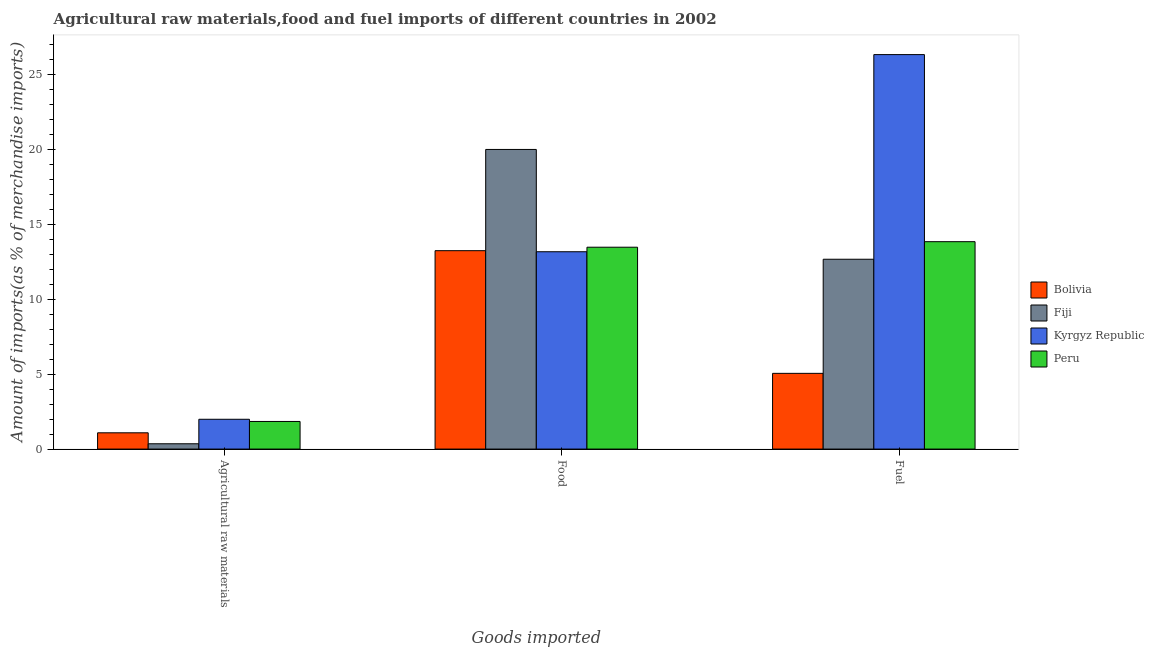How many different coloured bars are there?
Your answer should be compact. 4. Are the number of bars per tick equal to the number of legend labels?
Make the answer very short. Yes. How many bars are there on the 3rd tick from the left?
Provide a succinct answer. 4. What is the label of the 3rd group of bars from the left?
Give a very brief answer. Fuel. What is the percentage of raw materials imports in Kyrgyz Republic?
Your answer should be compact. 1.99. Across all countries, what is the maximum percentage of fuel imports?
Give a very brief answer. 26.32. Across all countries, what is the minimum percentage of fuel imports?
Ensure brevity in your answer.  5.05. In which country was the percentage of raw materials imports maximum?
Your answer should be very brief. Kyrgyz Republic. In which country was the percentage of fuel imports minimum?
Offer a very short reply. Bolivia. What is the total percentage of fuel imports in the graph?
Your answer should be very brief. 57.87. What is the difference between the percentage of fuel imports in Bolivia and that in Fiji?
Your answer should be compact. -7.61. What is the difference between the percentage of raw materials imports in Kyrgyz Republic and the percentage of fuel imports in Fiji?
Your answer should be compact. -10.68. What is the average percentage of food imports per country?
Your response must be concise. 14.97. What is the difference between the percentage of fuel imports and percentage of raw materials imports in Kyrgyz Republic?
Make the answer very short. 24.33. What is the ratio of the percentage of food imports in Fiji to that in Kyrgyz Republic?
Provide a succinct answer. 1.52. Is the difference between the percentage of fuel imports in Fiji and Bolivia greater than the difference between the percentage of food imports in Fiji and Bolivia?
Keep it short and to the point. Yes. What is the difference between the highest and the second highest percentage of food imports?
Give a very brief answer. 6.52. What is the difference between the highest and the lowest percentage of fuel imports?
Your response must be concise. 21.27. What does the 4th bar from the left in Agricultural raw materials represents?
Provide a short and direct response. Peru. What does the 4th bar from the right in Agricultural raw materials represents?
Make the answer very short. Bolivia. How many bars are there?
Give a very brief answer. 12. Are all the bars in the graph horizontal?
Make the answer very short. No. How many countries are there in the graph?
Keep it short and to the point. 4. Are the values on the major ticks of Y-axis written in scientific E-notation?
Your answer should be compact. No. Does the graph contain any zero values?
Make the answer very short. No. Does the graph contain grids?
Give a very brief answer. No. Where does the legend appear in the graph?
Provide a succinct answer. Center right. How many legend labels are there?
Give a very brief answer. 4. What is the title of the graph?
Provide a succinct answer. Agricultural raw materials,food and fuel imports of different countries in 2002. What is the label or title of the X-axis?
Offer a very short reply. Goods imported. What is the label or title of the Y-axis?
Offer a very short reply. Amount of imports(as % of merchandise imports). What is the Amount of imports(as % of merchandise imports) of Bolivia in Agricultural raw materials?
Make the answer very short. 1.09. What is the Amount of imports(as % of merchandise imports) of Fiji in Agricultural raw materials?
Give a very brief answer. 0.35. What is the Amount of imports(as % of merchandise imports) of Kyrgyz Republic in Agricultural raw materials?
Your answer should be compact. 1.99. What is the Amount of imports(as % of merchandise imports) of Peru in Agricultural raw materials?
Offer a terse response. 1.84. What is the Amount of imports(as % of merchandise imports) in Bolivia in Food?
Provide a short and direct response. 13.24. What is the Amount of imports(as % of merchandise imports) of Fiji in Food?
Keep it short and to the point. 19.99. What is the Amount of imports(as % of merchandise imports) of Kyrgyz Republic in Food?
Give a very brief answer. 13.17. What is the Amount of imports(as % of merchandise imports) in Peru in Food?
Offer a very short reply. 13.47. What is the Amount of imports(as % of merchandise imports) of Bolivia in Fuel?
Provide a succinct answer. 5.05. What is the Amount of imports(as % of merchandise imports) of Fiji in Fuel?
Your answer should be compact. 12.67. What is the Amount of imports(as % of merchandise imports) in Kyrgyz Republic in Fuel?
Your answer should be compact. 26.32. What is the Amount of imports(as % of merchandise imports) of Peru in Fuel?
Offer a terse response. 13.84. Across all Goods imported, what is the maximum Amount of imports(as % of merchandise imports) in Bolivia?
Provide a succinct answer. 13.24. Across all Goods imported, what is the maximum Amount of imports(as % of merchandise imports) in Fiji?
Provide a succinct answer. 19.99. Across all Goods imported, what is the maximum Amount of imports(as % of merchandise imports) of Kyrgyz Republic?
Ensure brevity in your answer.  26.32. Across all Goods imported, what is the maximum Amount of imports(as % of merchandise imports) in Peru?
Ensure brevity in your answer.  13.84. Across all Goods imported, what is the minimum Amount of imports(as % of merchandise imports) in Bolivia?
Your response must be concise. 1.09. Across all Goods imported, what is the minimum Amount of imports(as % of merchandise imports) in Fiji?
Offer a terse response. 0.35. Across all Goods imported, what is the minimum Amount of imports(as % of merchandise imports) of Kyrgyz Republic?
Make the answer very short. 1.99. Across all Goods imported, what is the minimum Amount of imports(as % of merchandise imports) in Peru?
Provide a short and direct response. 1.84. What is the total Amount of imports(as % of merchandise imports) of Bolivia in the graph?
Your answer should be very brief. 19.38. What is the total Amount of imports(as % of merchandise imports) in Fiji in the graph?
Make the answer very short. 33.01. What is the total Amount of imports(as % of merchandise imports) in Kyrgyz Republic in the graph?
Offer a terse response. 41.47. What is the total Amount of imports(as % of merchandise imports) in Peru in the graph?
Provide a short and direct response. 29.15. What is the difference between the Amount of imports(as % of merchandise imports) of Bolivia in Agricultural raw materials and that in Food?
Your response must be concise. -12.15. What is the difference between the Amount of imports(as % of merchandise imports) in Fiji in Agricultural raw materials and that in Food?
Make the answer very short. -19.64. What is the difference between the Amount of imports(as % of merchandise imports) in Kyrgyz Republic in Agricultural raw materials and that in Food?
Provide a succinct answer. -11.18. What is the difference between the Amount of imports(as % of merchandise imports) of Peru in Agricultural raw materials and that in Food?
Your answer should be very brief. -11.63. What is the difference between the Amount of imports(as % of merchandise imports) in Bolivia in Agricultural raw materials and that in Fuel?
Ensure brevity in your answer.  -3.97. What is the difference between the Amount of imports(as % of merchandise imports) of Fiji in Agricultural raw materials and that in Fuel?
Give a very brief answer. -12.31. What is the difference between the Amount of imports(as % of merchandise imports) in Kyrgyz Republic in Agricultural raw materials and that in Fuel?
Your answer should be very brief. -24.33. What is the difference between the Amount of imports(as % of merchandise imports) of Peru in Agricultural raw materials and that in Fuel?
Your response must be concise. -12. What is the difference between the Amount of imports(as % of merchandise imports) of Bolivia in Food and that in Fuel?
Keep it short and to the point. 8.18. What is the difference between the Amount of imports(as % of merchandise imports) in Fiji in Food and that in Fuel?
Make the answer very short. 7.33. What is the difference between the Amount of imports(as % of merchandise imports) of Kyrgyz Republic in Food and that in Fuel?
Your answer should be compact. -13.15. What is the difference between the Amount of imports(as % of merchandise imports) of Peru in Food and that in Fuel?
Keep it short and to the point. -0.37. What is the difference between the Amount of imports(as % of merchandise imports) of Bolivia in Agricultural raw materials and the Amount of imports(as % of merchandise imports) of Fiji in Food?
Your answer should be very brief. -18.91. What is the difference between the Amount of imports(as % of merchandise imports) of Bolivia in Agricultural raw materials and the Amount of imports(as % of merchandise imports) of Kyrgyz Republic in Food?
Give a very brief answer. -12.08. What is the difference between the Amount of imports(as % of merchandise imports) of Bolivia in Agricultural raw materials and the Amount of imports(as % of merchandise imports) of Peru in Food?
Make the answer very short. -12.38. What is the difference between the Amount of imports(as % of merchandise imports) in Fiji in Agricultural raw materials and the Amount of imports(as % of merchandise imports) in Kyrgyz Republic in Food?
Give a very brief answer. -12.81. What is the difference between the Amount of imports(as % of merchandise imports) in Fiji in Agricultural raw materials and the Amount of imports(as % of merchandise imports) in Peru in Food?
Keep it short and to the point. -13.11. What is the difference between the Amount of imports(as % of merchandise imports) in Kyrgyz Republic in Agricultural raw materials and the Amount of imports(as % of merchandise imports) in Peru in Food?
Provide a succinct answer. -11.48. What is the difference between the Amount of imports(as % of merchandise imports) of Bolivia in Agricultural raw materials and the Amount of imports(as % of merchandise imports) of Fiji in Fuel?
Give a very brief answer. -11.58. What is the difference between the Amount of imports(as % of merchandise imports) in Bolivia in Agricultural raw materials and the Amount of imports(as % of merchandise imports) in Kyrgyz Republic in Fuel?
Keep it short and to the point. -25.23. What is the difference between the Amount of imports(as % of merchandise imports) in Bolivia in Agricultural raw materials and the Amount of imports(as % of merchandise imports) in Peru in Fuel?
Your answer should be very brief. -12.75. What is the difference between the Amount of imports(as % of merchandise imports) of Fiji in Agricultural raw materials and the Amount of imports(as % of merchandise imports) of Kyrgyz Republic in Fuel?
Ensure brevity in your answer.  -25.97. What is the difference between the Amount of imports(as % of merchandise imports) in Fiji in Agricultural raw materials and the Amount of imports(as % of merchandise imports) in Peru in Fuel?
Offer a terse response. -13.48. What is the difference between the Amount of imports(as % of merchandise imports) in Kyrgyz Republic in Agricultural raw materials and the Amount of imports(as % of merchandise imports) in Peru in Fuel?
Make the answer very short. -11.85. What is the difference between the Amount of imports(as % of merchandise imports) in Bolivia in Food and the Amount of imports(as % of merchandise imports) in Fiji in Fuel?
Provide a succinct answer. 0.57. What is the difference between the Amount of imports(as % of merchandise imports) of Bolivia in Food and the Amount of imports(as % of merchandise imports) of Kyrgyz Republic in Fuel?
Offer a terse response. -13.08. What is the difference between the Amount of imports(as % of merchandise imports) in Bolivia in Food and the Amount of imports(as % of merchandise imports) in Peru in Fuel?
Offer a very short reply. -0.6. What is the difference between the Amount of imports(as % of merchandise imports) of Fiji in Food and the Amount of imports(as % of merchandise imports) of Kyrgyz Republic in Fuel?
Keep it short and to the point. -6.33. What is the difference between the Amount of imports(as % of merchandise imports) in Fiji in Food and the Amount of imports(as % of merchandise imports) in Peru in Fuel?
Your answer should be compact. 6.15. What is the difference between the Amount of imports(as % of merchandise imports) of Kyrgyz Republic in Food and the Amount of imports(as % of merchandise imports) of Peru in Fuel?
Make the answer very short. -0.67. What is the average Amount of imports(as % of merchandise imports) in Bolivia per Goods imported?
Your answer should be very brief. 6.46. What is the average Amount of imports(as % of merchandise imports) in Fiji per Goods imported?
Make the answer very short. 11. What is the average Amount of imports(as % of merchandise imports) of Kyrgyz Republic per Goods imported?
Your response must be concise. 13.82. What is the average Amount of imports(as % of merchandise imports) of Peru per Goods imported?
Provide a succinct answer. 9.72. What is the difference between the Amount of imports(as % of merchandise imports) of Bolivia and Amount of imports(as % of merchandise imports) of Fiji in Agricultural raw materials?
Your answer should be compact. 0.73. What is the difference between the Amount of imports(as % of merchandise imports) of Bolivia and Amount of imports(as % of merchandise imports) of Kyrgyz Republic in Agricultural raw materials?
Your response must be concise. -0.9. What is the difference between the Amount of imports(as % of merchandise imports) of Bolivia and Amount of imports(as % of merchandise imports) of Peru in Agricultural raw materials?
Give a very brief answer. -0.76. What is the difference between the Amount of imports(as % of merchandise imports) of Fiji and Amount of imports(as % of merchandise imports) of Kyrgyz Republic in Agricultural raw materials?
Provide a succinct answer. -1.64. What is the difference between the Amount of imports(as % of merchandise imports) of Fiji and Amount of imports(as % of merchandise imports) of Peru in Agricultural raw materials?
Provide a succinct answer. -1.49. What is the difference between the Amount of imports(as % of merchandise imports) in Kyrgyz Republic and Amount of imports(as % of merchandise imports) in Peru in Agricultural raw materials?
Keep it short and to the point. 0.15. What is the difference between the Amount of imports(as % of merchandise imports) in Bolivia and Amount of imports(as % of merchandise imports) in Fiji in Food?
Give a very brief answer. -6.75. What is the difference between the Amount of imports(as % of merchandise imports) in Bolivia and Amount of imports(as % of merchandise imports) in Kyrgyz Republic in Food?
Provide a succinct answer. 0.07. What is the difference between the Amount of imports(as % of merchandise imports) in Bolivia and Amount of imports(as % of merchandise imports) in Peru in Food?
Offer a terse response. -0.23. What is the difference between the Amount of imports(as % of merchandise imports) of Fiji and Amount of imports(as % of merchandise imports) of Kyrgyz Republic in Food?
Your answer should be very brief. 6.83. What is the difference between the Amount of imports(as % of merchandise imports) of Fiji and Amount of imports(as % of merchandise imports) of Peru in Food?
Offer a terse response. 6.52. What is the difference between the Amount of imports(as % of merchandise imports) of Kyrgyz Republic and Amount of imports(as % of merchandise imports) of Peru in Food?
Your response must be concise. -0.3. What is the difference between the Amount of imports(as % of merchandise imports) in Bolivia and Amount of imports(as % of merchandise imports) in Fiji in Fuel?
Ensure brevity in your answer.  -7.61. What is the difference between the Amount of imports(as % of merchandise imports) of Bolivia and Amount of imports(as % of merchandise imports) of Kyrgyz Republic in Fuel?
Offer a terse response. -21.27. What is the difference between the Amount of imports(as % of merchandise imports) in Bolivia and Amount of imports(as % of merchandise imports) in Peru in Fuel?
Make the answer very short. -8.78. What is the difference between the Amount of imports(as % of merchandise imports) of Fiji and Amount of imports(as % of merchandise imports) of Kyrgyz Republic in Fuel?
Your answer should be very brief. -13.65. What is the difference between the Amount of imports(as % of merchandise imports) in Fiji and Amount of imports(as % of merchandise imports) in Peru in Fuel?
Make the answer very short. -1.17. What is the difference between the Amount of imports(as % of merchandise imports) in Kyrgyz Republic and Amount of imports(as % of merchandise imports) in Peru in Fuel?
Your answer should be very brief. 12.48. What is the ratio of the Amount of imports(as % of merchandise imports) of Bolivia in Agricultural raw materials to that in Food?
Provide a succinct answer. 0.08. What is the ratio of the Amount of imports(as % of merchandise imports) in Fiji in Agricultural raw materials to that in Food?
Give a very brief answer. 0.02. What is the ratio of the Amount of imports(as % of merchandise imports) in Kyrgyz Republic in Agricultural raw materials to that in Food?
Give a very brief answer. 0.15. What is the ratio of the Amount of imports(as % of merchandise imports) of Peru in Agricultural raw materials to that in Food?
Give a very brief answer. 0.14. What is the ratio of the Amount of imports(as % of merchandise imports) in Bolivia in Agricultural raw materials to that in Fuel?
Keep it short and to the point. 0.21. What is the ratio of the Amount of imports(as % of merchandise imports) of Fiji in Agricultural raw materials to that in Fuel?
Offer a very short reply. 0.03. What is the ratio of the Amount of imports(as % of merchandise imports) in Kyrgyz Republic in Agricultural raw materials to that in Fuel?
Keep it short and to the point. 0.08. What is the ratio of the Amount of imports(as % of merchandise imports) in Peru in Agricultural raw materials to that in Fuel?
Provide a succinct answer. 0.13. What is the ratio of the Amount of imports(as % of merchandise imports) of Bolivia in Food to that in Fuel?
Provide a short and direct response. 2.62. What is the ratio of the Amount of imports(as % of merchandise imports) in Fiji in Food to that in Fuel?
Provide a short and direct response. 1.58. What is the ratio of the Amount of imports(as % of merchandise imports) in Kyrgyz Republic in Food to that in Fuel?
Make the answer very short. 0.5. What is the ratio of the Amount of imports(as % of merchandise imports) of Peru in Food to that in Fuel?
Ensure brevity in your answer.  0.97. What is the difference between the highest and the second highest Amount of imports(as % of merchandise imports) of Bolivia?
Keep it short and to the point. 8.18. What is the difference between the highest and the second highest Amount of imports(as % of merchandise imports) of Fiji?
Ensure brevity in your answer.  7.33. What is the difference between the highest and the second highest Amount of imports(as % of merchandise imports) in Kyrgyz Republic?
Your answer should be compact. 13.15. What is the difference between the highest and the second highest Amount of imports(as % of merchandise imports) in Peru?
Make the answer very short. 0.37. What is the difference between the highest and the lowest Amount of imports(as % of merchandise imports) in Bolivia?
Keep it short and to the point. 12.15. What is the difference between the highest and the lowest Amount of imports(as % of merchandise imports) of Fiji?
Offer a terse response. 19.64. What is the difference between the highest and the lowest Amount of imports(as % of merchandise imports) of Kyrgyz Republic?
Offer a very short reply. 24.33. What is the difference between the highest and the lowest Amount of imports(as % of merchandise imports) in Peru?
Make the answer very short. 12. 